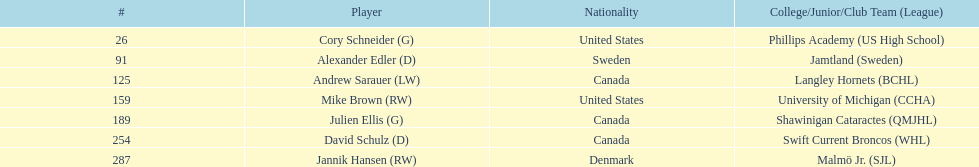Would you mind parsing the complete table? {'header': ['#', 'Player', 'Nationality', 'College/Junior/Club Team (League)'], 'rows': [['26', 'Cory Schneider (G)', 'United States', 'Phillips Academy (US High School)'], ['91', 'Alexander Edler (D)', 'Sweden', 'Jamtland (Sweden)'], ['125', 'Andrew Sarauer (LW)', 'Canada', 'Langley Hornets (BCHL)'], ['159', 'Mike Brown (RW)', 'United States', 'University of Michigan (CCHA)'], ['189', 'Julien Ellis (G)', 'Canada', 'Shawinigan Cataractes (QMJHL)'], ['254', 'David Schulz (D)', 'Canada', 'Swift Current Broncos (WHL)'], ['287', 'Jannik Hansen (RW)', 'Denmark', 'Malmö Jr. (SJL)']]} What is the number of canadian players listed? 3. 